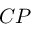<formula> <loc_0><loc_0><loc_500><loc_500>C P</formula> 